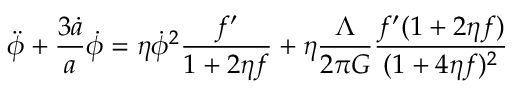Convert formula to latex. <formula><loc_0><loc_0><loc_500><loc_500>\ddot { \phi } + \frac { 3 \dot { a } } { a } \dot { \phi } = \eta \dot { \phi } ^ { 2 } \frac { f ^ { \prime } } { 1 + 2 \eta f } + \eta \frac { \Lambda } { 2 \pi G } \frac { f ^ { \prime } ( 1 + 2 \eta f ) } { ( 1 + 4 \eta f ) ^ { 2 } }</formula> 